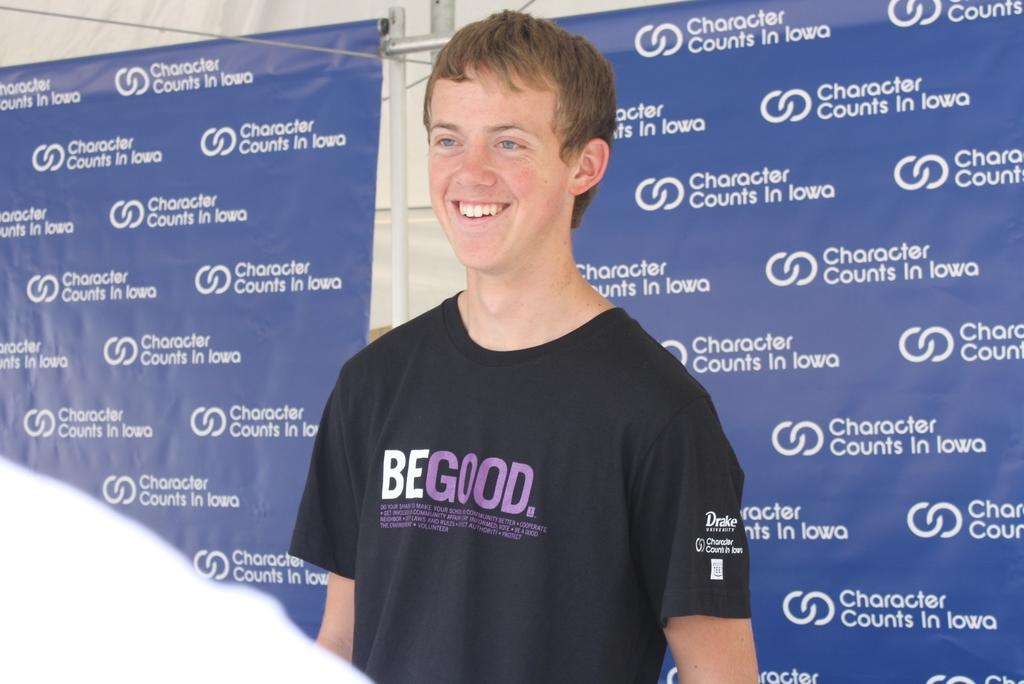<image>
Summarize the visual content of the image. A man smiling and wearing a Be Good shirt. 